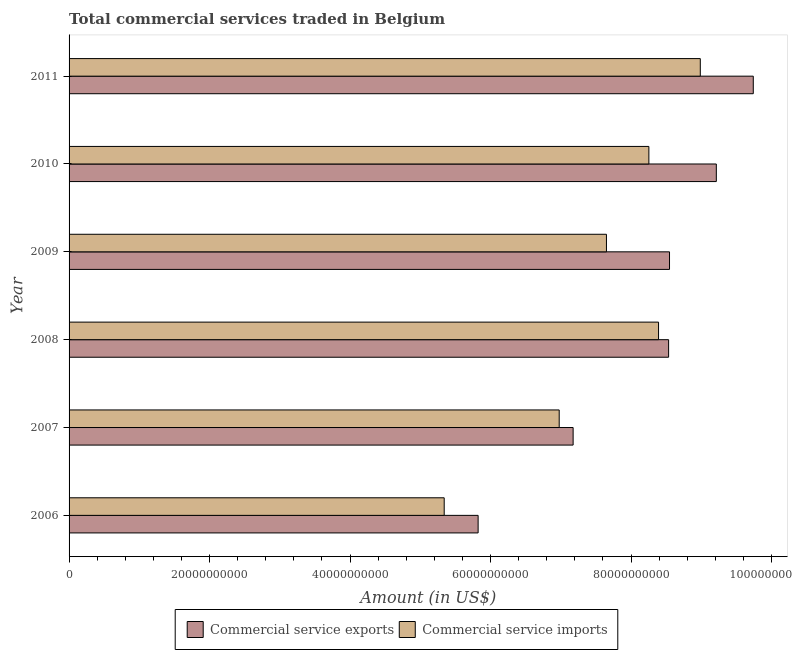How many different coloured bars are there?
Provide a short and direct response. 2. How many groups of bars are there?
Offer a very short reply. 6. Are the number of bars on each tick of the Y-axis equal?
Make the answer very short. Yes. How many bars are there on the 4th tick from the bottom?
Your answer should be very brief. 2. What is the label of the 4th group of bars from the top?
Provide a short and direct response. 2008. What is the amount of commercial service exports in 2007?
Provide a short and direct response. 7.18e+1. Across all years, what is the maximum amount of commercial service imports?
Provide a short and direct response. 8.99e+1. Across all years, what is the minimum amount of commercial service exports?
Keep it short and to the point. 5.82e+1. What is the total amount of commercial service exports in the graph?
Make the answer very short. 4.90e+11. What is the difference between the amount of commercial service imports in 2006 and that in 2008?
Make the answer very short. -3.05e+1. What is the difference between the amount of commercial service exports in 2010 and the amount of commercial service imports in 2011?
Your answer should be compact. 2.28e+09. What is the average amount of commercial service exports per year?
Your answer should be very brief. 8.17e+1. In the year 2010, what is the difference between the amount of commercial service imports and amount of commercial service exports?
Provide a short and direct response. -9.60e+09. In how many years, is the amount of commercial service imports greater than 36000000000 US$?
Keep it short and to the point. 6. What is the ratio of the amount of commercial service exports in 2008 to that in 2010?
Keep it short and to the point. 0.93. Is the amount of commercial service imports in 2009 less than that in 2011?
Offer a terse response. Yes. Is the difference between the amount of commercial service imports in 2007 and 2010 greater than the difference between the amount of commercial service exports in 2007 and 2010?
Give a very brief answer. Yes. What is the difference between the highest and the second highest amount of commercial service imports?
Provide a succinct answer. 5.94e+09. What is the difference between the highest and the lowest amount of commercial service exports?
Your response must be concise. 3.92e+1. Is the sum of the amount of commercial service imports in 2006 and 2009 greater than the maximum amount of commercial service exports across all years?
Ensure brevity in your answer.  Yes. What does the 2nd bar from the top in 2011 represents?
Offer a terse response. Commercial service exports. What does the 2nd bar from the bottom in 2010 represents?
Offer a terse response. Commercial service imports. How many bars are there?
Provide a short and direct response. 12. Are all the bars in the graph horizontal?
Keep it short and to the point. Yes. What is the difference between two consecutive major ticks on the X-axis?
Offer a terse response. 2.00e+1. Does the graph contain any zero values?
Offer a very short reply. No. Does the graph contain grids?
Your answer should be very brief. No. How are the legend labels stacked?
Your answer should be compact. Horizontal. What is the title of the graph?
Your answer should be very brief. Total commercial services traded in Belgium. What is the label or title of the X-axis?
Provide a short and direct response. Amount (in US$). What is the Amount (in US$) of Commercial service exports in 2006?
Your answer should be compact. 5.82e+1. What is the Amount (in US$) in Commercial service imports in 2006?
Ensure brevity in your answer.  5.34e+1. What is the Amount (in US$) of Commercial service exports in 2007?
Your answer should be very brief. 7.18e+1. What is the Amount (in US$) of Commercial service imports in 2007?
Your answer should be very brief. 6.98e+1. What is the Amount (in US$) in Commercial service exports in 2008?
Your response must be concise. 8.54e+1. What is the Amount (in US$) in Commercial service imports in 2008?
Offer a terse response. 8.39e+1. What is the Amount (in US$) of Commercial service exports in 2009?
Keep it short and to the point. 8.55e+1. What is the Amount (in US$) in Commercial service imports in 2009?
Your response must be concise. 7.65e+1. What is the Amount (in US$) in Commercial service exports in 2010?
Provide a short and direct response. 9.21e+1. What is the Amount (in US$) of Commercial service imports in 2010?
Offer a very short reply. 8.25e+1. What is the Amount (in US$) of Commercial service exports in 2011?
Make the answer very short. 9.74e+1. What is the Amount (in US$) in Commercial service imports in 2011?
Your answer should be compact. 8.99e+1. Across all years, what is the maximum Amount (in US$) of Commercial service exports?
Give a very brief answer. 9.74e+1. Across all years, what is the maximum Amount (in US$) of Commercial service imports?
Your answer should be compact. 8.99e+1. Across all years, what is the minimum Amount (in US$) of Commercial service exports?
Provide a short and direct response. 5.82e+1. Across all years, what is the minimum Amount (in US$) of Commercial service imports?
Your answer should be compact. 5.34e+1. What is the total Amount (in US$) of Commercial service exports in the graph?
Offer a very short reply. 4.90e+11. What is the total Amount (in US$) in Commercial service imports in the graph?
Your answer should be very brief. 4.56e+11. What is the difference between the Amount (in US$) in Commercial service exports in 2006 and that in 2007?
Provide a short and direct response. -1.35e+1. What is the difference between the Amount (in US$) in Commercial service imports in 2006 and that in 2007?
Your answer should be very brief. -1.64e+1. What is the difference between the Amount (in US$) of Commercial service exports in 2006 and that in 2008?
Keep it short and to the point. -2.71e+1. What is the difference between the Amount (in US$) of Commercial service imports in 2006 and that in 2008?
Offer a very short reply. -3.05e+1. What is the difference between the Amount (in US$) in Commercial service exports in 2006 and that in 2009?
Your answer should be compact. -2.72e+1. What is the difference between the Amount (in US$) of Commercial service imports in 2006 and that in 2009?
Your answer should be very brief. -2.31e+1. What is the difference between the Amount (in US$) of Commercial service exports in 2006 and that in 2010?
Ensure brevity in your answer.  -3.39e+1. What is the difference between the Amount (in US$) in Commercial service imports in 2006 and that in 2010?
Make the answer very short. -2.91e+1. What is the difference between the Amount (in US$) of Commercial service exports in 2006 and that in 2011?
Ensure brevity in your answer.  -3.92e+1. What is the difference between the Amount (in US$) in Commercial service imports in 2006 and that in 2011?
Give a very brief answer. -3.65e+1. What is the difference between the Amount (in US$) of Commercial service exports in 2007 and that in 2008?
Your answer should be compact. -1.36e+1. What is the difference between the Amount (in US$) of Commercial service imports in 2007 and that in 2008?
Offer a very short reply. -1.41e+1. What is the difference between the Amount (in US$) of Commercial service exports in 2007 and that in 2009?
Give a very brief answer. -1.37e+1. What is the difference between the Amount (in US$) of Commercial service imports in 2007 and that in 2009?
Make the answer very short. -6.73e+09. What is the difference between the Amount (in US$) in Commercial service exports in 2007 and that in 2010?
Offer a terse response. -2.04e+1. What is the difference between the Amount (in US$) in Commercial service imports in 2007 and that in 2010?
Make the answer very short. -1.28e+1. What is the difference between the Amount (in US$) in Commercial service exports in 2007 and that in 2011?
Offer a very short reply. -2.56e+1. What is the difference between the Amount (in US$) in Commercial service imports in 2007 and that in 2011?
Your answer should be compact. -2.01e+1. What is the difference between the Amount (in US$) of Commercial service exports in 2008 and that in 2009?
Your answer should be compact. -1.30e+08. What is the difference between the Amount (in US$) of Commercial service imports in 2008 and that in 2009?
Provide a short and direct response. 7.42e+09. What is the difference between the Amount (in US$) of Commercial service exports in 2008 and that in 2010?
Ensure brevity in your answer.  -6.79e+09. What is the difference between the Amount (in US$) of Commercial service imports in 2008 and that in 2010?
Provide a succinct answer. 1.38e+09. What is the difference between the Amount (in US$) in Commercial service exports in 2008 and that in 2011?
Provide a short and direct response. -1.21e+1. What is the difference between the Amount (in US$) in Commercial service imports in 2008 and that in 2011?
Offer a very short reply. -5.94e+09. What is the difference between the Amount (in US$) in Commercial service exports in 2009 and that in 2010?
Ensure brevity in your answer.  -6.66e+09. What is the difference between the Amount (in US$) in Commercial service imports in 2009 and that in 2010?
Provide a short and direct response. -6.04e+09. What is the difference between the Amount (in US$) of Commercial service exports in 2009 and that in 2011?
Give a very brief answer. -1.19e+1. What is the difference between the Amount (in US$) in Commercial service imports in 2009 and that in 2011?
Keep it short and to the point. -1.34e+1. What is the difference between the Amount (in US$) of Commercial service exports in 2010 and that in 2011?
Give a very brief answer. -5.26e+09. What is the difference between the Amount (in US$) in Commercial service imports in 2010 and that in 2011?
Make the answer very short. -7.32e+09. What is the difference between the Amount (in US$) in Commercial service exports in 2006 and the Amount (in US$) in Commercial service imports in 2007?
Give a very brief answer. -1.15e+1. What is the difference between the Amount (in US$) in Commercial service exports in 2006 and the Amount (in US$) in Commercial service imports in 2008?
Provide a succinct answer. -2.57e+1. What is the difference between the Amount (in US$) in Commercial service exports in 2006 and the Amount (in US$) in Commercial service imports in 2009?
Provide a short and direct response. -1.83e+1. What is the difference between the Amount (in US$) of Commercial service exports in 2006 and the Amount (in US$) of Commercial service imports in 2010?
Make the answer very short. -2.43e+1. What is the difference between the Amount (in US$) of Commercial service exports in 2006 and the Amount (in US$) of Commercial service imports in 2011?
Keep it short and to the point. -3.16e+1. What is the difference between the Amount (in US$) of Commercial service exports in 2007 and the Amount (in US$) of Commercial service imports in 2008?
Keep it short and to the point. -1.22e+1. What is the difference between the Amount (in US$) of Commercial service exports in 2007 and the Amount (in US$) of Commercial service imports in 2009?
Offer a very short reply. -4.74e+09. What is the difference between the Amount (in US$) in Commercial service exports in 2007 and the Amount (in US$) in Commercial service imports in 2010?
Provide a succinct answer. -1.08e+1. What is the difference between the Amount (in US$) of Commercial service exports in 2007 and the Amount (in US$) of Commercial service imports in 2011?
Provide a short and direct response. -1.81e+1. What is the difference between the Amount (in US$) in Commercial service exports in 2008 and the Amount (in US$) in Commercial service imports in 2009?
Offer a terse response. 8.85e+09. What is the difference between the Amount (in US$) of Commercial service exports in 2008 and the Amount (in US$) of Commercial service imports in 2010?
Make the answer very short. 2.81e+09. What is the difference between the Amount (in US$) in Commercial service exports in 2008 and the Amount (in US$) in Commercial service imports in 2011?
Your response must be concise. -4.51e+09. What is the difference between the Amount (in US$) in Commercial service exports in 2009 and the Amount (in US$) in Commercial service imports in 2010?
Keep it short and to the point. 2.94e+09. What is the difference between the Amount (in US$) in Commercial service exports in 2009 and the Amount (in US$) in Commercial service imports in 2011?
Your answer should be compact. -4.38e+09. What is the difference between the Amount (in US$) in Commercial service exports in 2010 and the Amount (in US$) in Commercial service imports in 2011?
Provide a short and direct response. 2.28e+09. What is the average Amount (in US$) in Commercial service exports per year?
Provide a short and direct response. 8.17e+1. What is the average Amount (in US$) in Commercial service imports per year?
Provide a succinct answer. 7.60e+1. In the year 2006, what is the difference between the Amount (in US$) in Commercial service exports and Amount (in US$) in Commercial service imports?
Offer a very short reply. 4.83e+09. In the year 2007, what is the difference between the Amount (in US$) in Commercial service exports and Amount (in US$) in Commercial service imports?
Provide a short and direct response. 1.98e+09. In the year 2008, what is the difference between the Amount (in US$) of Commercial service exports and Amount (in US$) of Commercial service imports?
Provide a succinct answer. 1.43e+09. In the year 2009, what is the difference between the Amount (in US$) of Commercial service exports and Amount (in US$) of Commercial service imports?
Keep it short and to the point. 8.98e+09. In the year 2010, what is the difference between the Amount (in US$) in Commercial service exports and Amount (in US$) in Commercial service imports?
Keep it short and to the point. 9.60e+09. In the year 2011, what is the difference between the Amount (in US$) in Commercial service exports and Amount (in US$) in Commercial service imports?
Provide a short and direct response. 7.54e+09. What is the ratio of the Amount (in US$) of Commercial service exports in 2006 to that in 2007?
Your answer should be compact. 0.81. What is the ratio of the Amount (in US$) in Commercial service imports in 2006 to that in 2007?
Offer a terse response. 0.77. What is the ratio of the Amount (in US$) of Commercial service exports in 2006 to that in 2008?
Make the answer very short. 0.68. What is the ratio of the Amount (in US$) of Commercial service imports in 2006 to that in 2008?
Offer a terse response. 0.64. What is the ratio of the Amount (in US$) in Commercial service exports in 2006 to that in 2009?
Your response must be concise. 0.68. What is the ratio of the Amount (in US$) in Commercial service imports in 2006 to that in 2009?
Keep it short and to the point. 0.7. What is the ratio of the Amount (in US$) in Commercial service exports in 2006 to that in 2010?
Give a very brief answer. 0.63. What is the ratio of the Amount (in US$) in Commercial service imports in 2006 to that in 2010?
Provide a succinct answer. 0.65. What is the ratio of the Amount (in US$) in Commercial service exports in 2006 to that in 2011?
Your answer should be compact. 0.6. What is the ratio of the Amount (in US$) in Commercial service imports in 2006 to that in 2011?
Offer a terse response. 0.59. What is the ratio of the Amount (in US$) in Commercial service exports in 2007 to that in 2008?
Offer a terse response. 0.84. What is the ratio of the Amount (in US$) in Commercial service imports in 2007 to that in 2008?
Provide a succinct answer. 0.83. What is the ratio of the Amount (in US$) in Commercial service exports in 2007 to that in 2009?
Provide a short and direct response. 0.84. What is the ratio of the Amount (in US$) of Commercial service imports in 2007 to that in 2009?
Your answer should be compact. 0.91. What is the ratio of the Amount (in US$) of Commercial service exports in 2007 to that in 2010?
Provide a succinct answer. 0.78. What is the ratio of the Amount (in US$) in Commercial service imports in 2007 to that in 2010?
Provide a succinct answer. 0.85. What is the ratio of the Amount (in US$) of Commercial service exports in 2007 to that in 2011?
Offer a very short reply. 0.74. What is the ratio of the Amount (in US$) of Commercial service imports in 2007 to that in 2011?
Offer a very short reply. 0.78. What is the ratio of the Amount (in US$) in Commercial service imports in 2008 to that in 2009?
Keep it short and to the point. 1.1. What is the ratio of the Amount (in US$) in Commercial service exports in 2008 to that in 2010?
Your answer should be compact. 0.93. What is the ratio of the Amount (in US$) of Commercial service imports in 2008 to that in 2010?
Make the answer very short. 1.02. What is the ratio of the Amount (in US$) of Commercial service exports in 2008 to that in 2011?
Provide a short and direct response. 0.88. What is the ratio of the Amount (in US$) in Commercial service imports in 2008 to that in 2011?
Your response must be concise. 0.93. What is the ratio of the Amount (in US$) of Commercial service exports in 2009 to that in 2010?
Offer a terse response. 0.93. What is the ratio of the Amount (in US$) of Commercial service imports in 2009 to that in 2010?
Provide a short and direct response. 0.93. What is the ratio of the Amount (in US$) in Commercial service exports in 2009 to that in 2011?
Your answer should be very brief. 0.88. What is the ratio of the Amount (in US$) of Commercial service imports in 2009 to that in 2011?
Provide a short and direct response. 0.85. What is the ratio of the Amount (in US$) of Commercial service exports in 2010 to that in 2011?
Offer a very short reply. 0.95. What is the ratio of the Amount (in US$) in Commercial service imports in 2010 to that in 2011?
Offer a very short reply. 0.92. What is the difference between the highest and the second highest Amount (in US$) of Commercial service exports?
Offer a very short reply. 5.26e+09. What is the difference between the highest and the second highest Amount (in US$) in Commercial service imports?
Provide a short and direct response. 5.94e+09. What is the difference between the highest and the lowest Amount (in US$) in Commercial service exports?
Your answer should be very brief. 3.92e+1. What is the difference between the highest and the lowest Amount (in US$) of Commercial service imports?
Your answer should be very brief. 3.65e+1. 